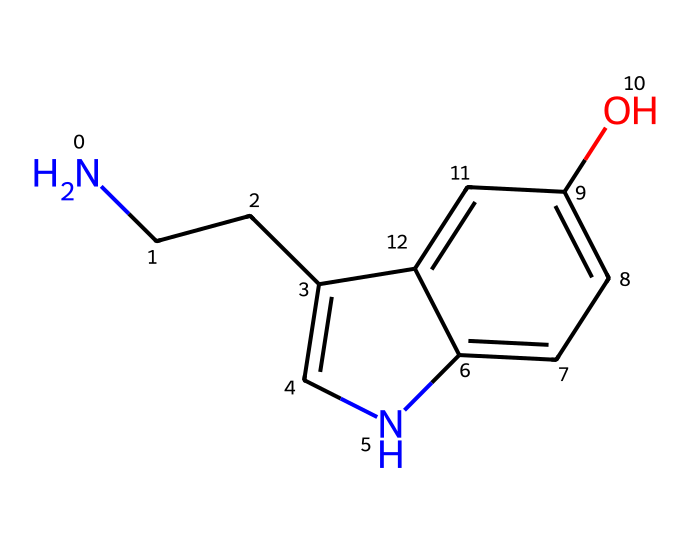What is the molecular formula of serotonin? To determine the molecular formula, we can analyze the SMILES representation: NCC refers to two carbon atoms and one nitrogen atom, c1c[nH] indicates aromatic carbon atoms and nitrogen, and c2ccc(O) indicates additional carbons and an oxygen atom. Counting these gives a total of 10 carbon atoms (C), 12 hydrogen atoms (H), 1 nitrogen atom (N), and 1 oxygen atom (O). Thus, the molecular formula is C10H12N2O.
Answer: C10H12N2O How many nitrogen atoms are present in serotonin? By examining the SMILES string, NCC indicates one nitrogen, c[nH] indicates one additional nitrogen. Adding them together results in a total of 2 nitrogen atoms.
Answer: 2 What type of functional group does the hydroxyl (-OH) represent in serotonin? The hydroxyl group (-OH) in the structure signifies that this compound has an alcohol functional group. The presence of this group impacts the chemical properties related to solubility and reactivity.
Answer: alcohol What structural feature indicates that serotonin can act as a neurotransmitter? Serotonin contains an amine group (N in NCC) which is characteristic of neurotransmitters. This amine functionality allows serotonin to interact with receptors in the nervous system, facilitating its role in mood regulation.
Answer: amine group Which part of the serotonin structure contributes to its aromatic character? The presence of the cyclic arrangement and alternating double bonds in the aromatic rings (c1c and c2ccc) indicates that these carbon atoms are part of an aromatic system. This is characteristic for many neurotransmitters that participate in biochemical signaling.
Answer: aromatic rings What role does the hydroxyl group play in serotonin's water solubility? The hydroxyl group (-OH) enhances the hydrophilicity of serotonin, increasing its ability to dissolve in water due to the ability to form hydrogen bonds with water molecules. This is crucial for its transport and function as a neurotransmitter in aqueous environments.
Answer: enhances solubility 